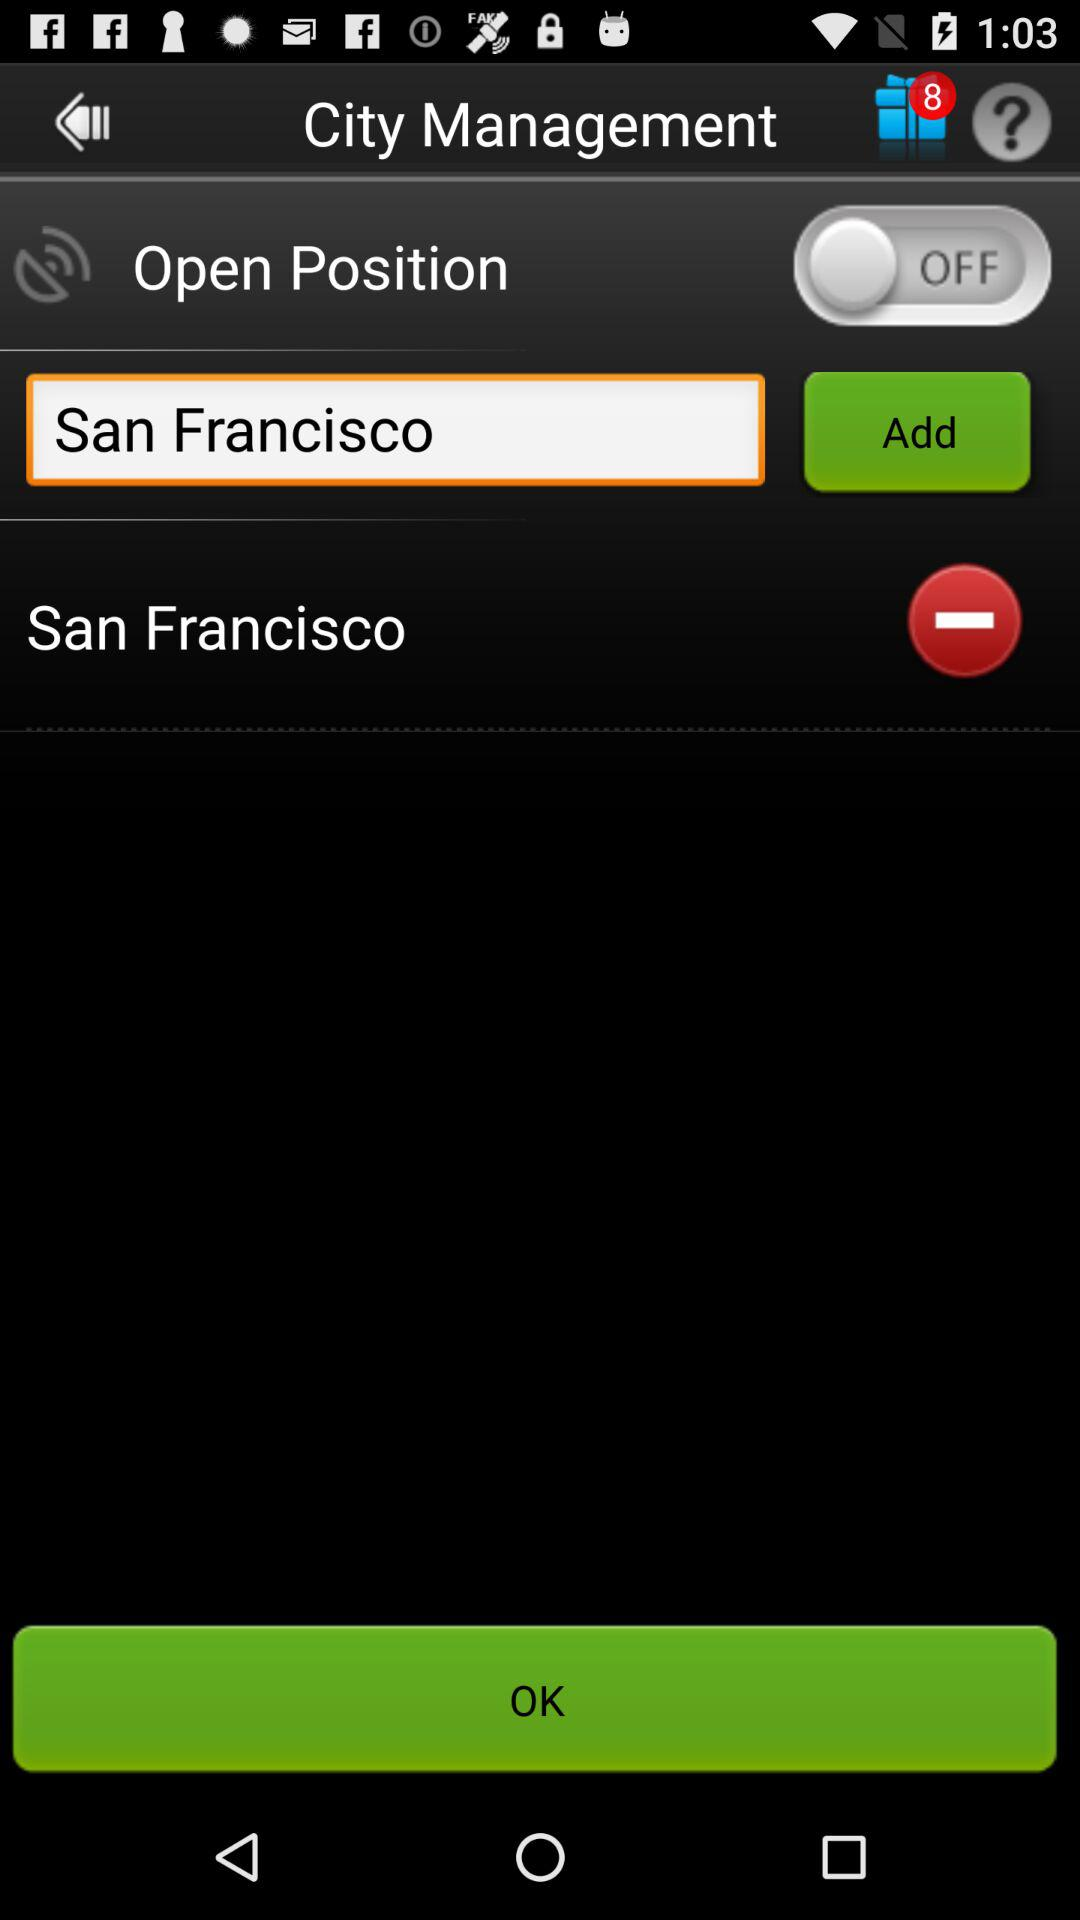How many gift items are available on the screen? There are 8 gift items available on the screen. 